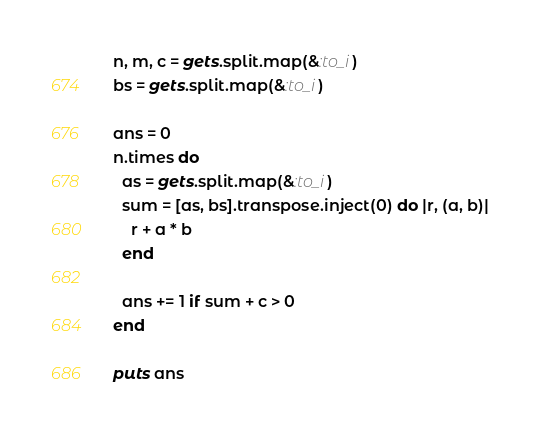<code> <loc_0><loc_0><loc_500><loc_500><_Ruby_>n, m, c = gets.split.map(&:to_i)
bs = gets.split.map(&:to_i)

ans = 0
n.times do
  as = gets.split.map(&:to_i)
  sum = [as, bs].transpose.inject(0) do |r, (a, b)|
    r + a * b
  end

  ans += 1 if sum + c > 0
end

puts ans
</code> 